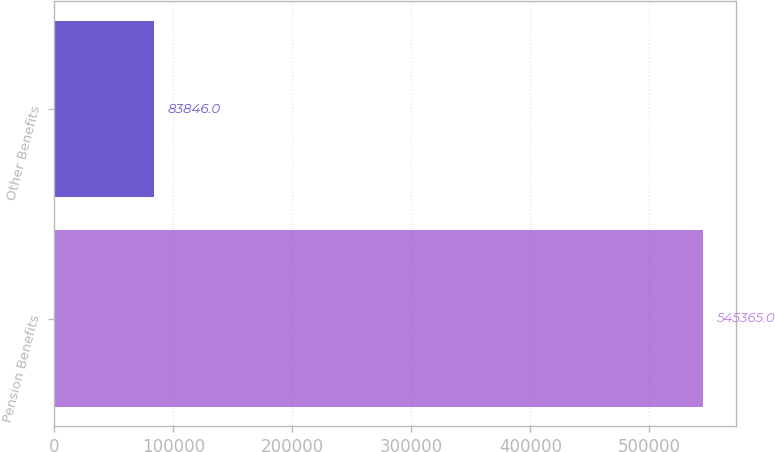Convert chart. <chart><loc_0><loc_0><loc_500><loc_500><bar_chart><fcel>Pension Benefits<fcel>Other Benefits<nl><fcel>545365<fcel>83846<nl></chart> 